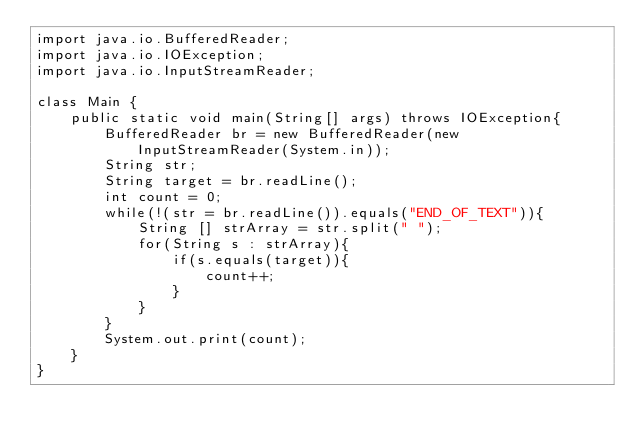<code> <loc_0><loc_0><loc_500><loc_500><_Java_>import java.io.BufferedReader;
import java.io.IOException;
import java.io.InputStreamReader;

class Main {
	public static void main(String[] args) throws IOException{
		BufferedReader br = new BufferedReader(new InputStreamReader(System.in));
		String str;
		String target = br.readLine();
		int count = 0;
		while(!(str = br.readLine()).equals("END_OF_TEXT")){
			String [] strArray = str.split(" ");
			for(String s : strArray){
				if(s.equals(target)){
					count++;
				}
			}
		}
		System.out.print(count);
    }
}</code> 